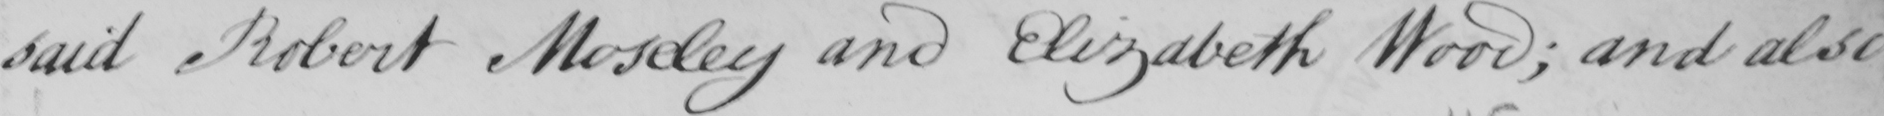What is written in this line of handwriting? said Robert Moseley and Elizabeth Wood ; and also 